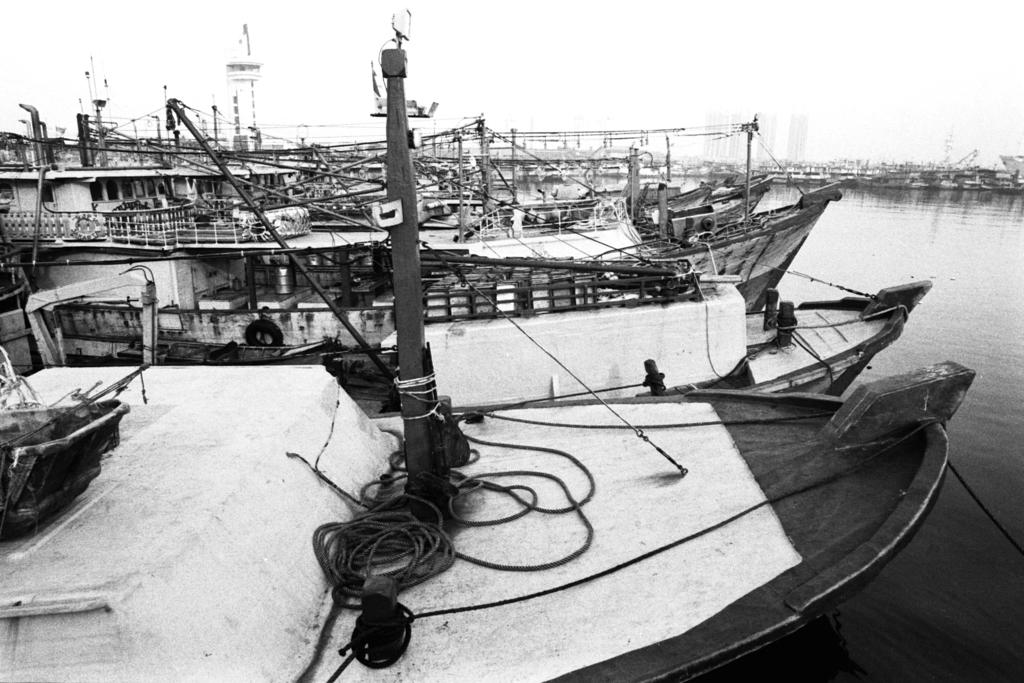What is the main subject of the image? The main subject of the image is water. What is present in the water? There are boats in the water. Can you describe any specific features of the boats? A rope is visible on one of the boats. What is the color scheme of the image? The image is black and white in color. Where is the flower located in the image? There is no flower present in the image. What color is the butter in the image? There is no butter present in the image. 